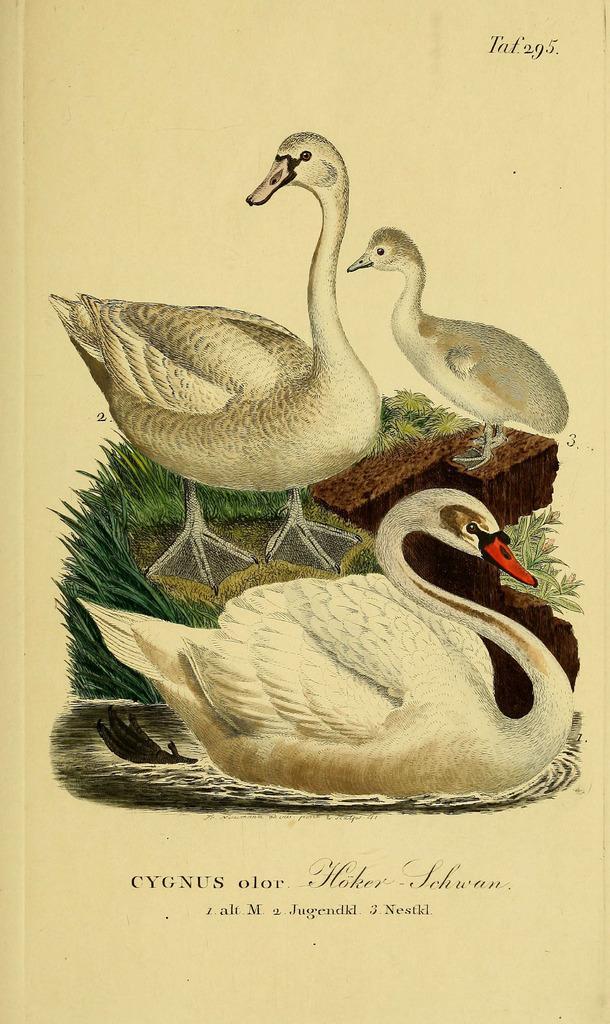Please provide a concise description of this image. In this image there is a painting of few images and some text. A duck is in water. Behind a duck is standing on the land having some grass and few plants on it. A duck is standing on the rock. Bottom of image there is some text. 